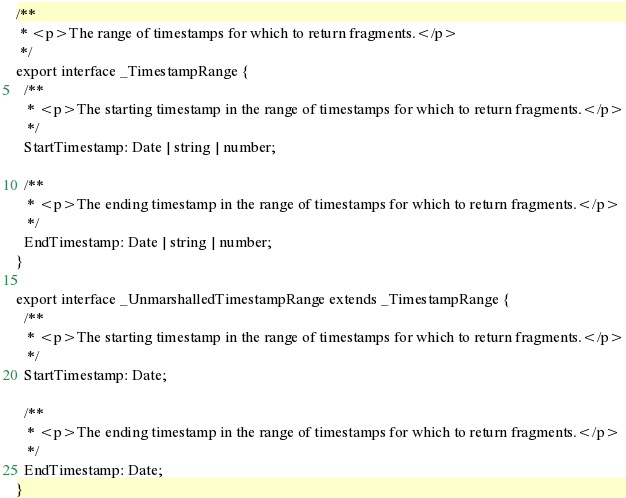Convert code to text. <code><loc_0><loc_0><loc_500><loc_500><_TypeScript_>/**
 * <p>The range of timestamps for which to return fragments.</p>
 */
export interface _TimestampRange {
  /**
   * <p>The starting timestamp in the range of timestamps for which to return fragments.</p>
   */
  StartTimestamp: Date | string | number;

  /**
   * <p>The ending timestamp in the range of timestamps for which to return fragments.</p>
   */
  EndTimestamp: Date | string | number;
}

export interface _UnmarshalledTimestampRange extends _TimestampRange {
  /**
   * <p>The starting timestamp in the range of timestamps for which to return fragments.</p>
   */
  StartTimestamp: Date;

  /**
   * <p>The ending timestamp in the range of timestamps for which to return fragments.</p>
   */
  EndTimestamp: Date;
}
</code> 